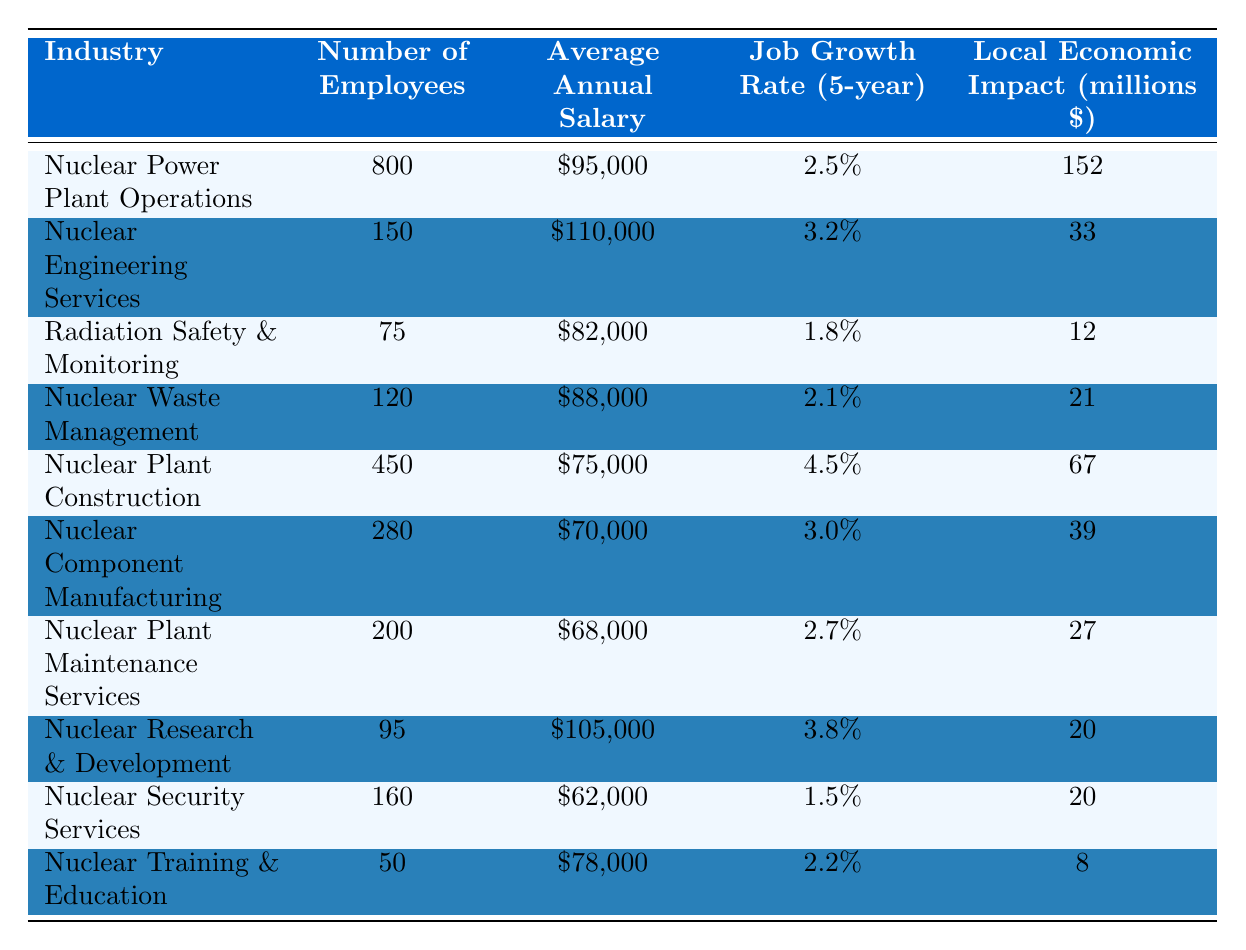What is the average annual salary of employees in Nuclear Power Plant Operations? The salary for Nuclear Power Plant Operations is listed as $95,000 in the table.
Answer: $95,000 Which industry has the highest job growth rate over the next five years? Nuclear Plant Construction has the highest job growth rate at 4.5% according to the table.
Answer: 4.5% What is the local economic impact of Nuclear Engineering Services? The table shows that the local economic impact of Nuclear Engineering Services is $33 million.
Answer: $33 million How many employees work in Nuclear Security Services? The table indicates that Nuclear Security Services employs 160 people.
Answer: 160 What is the total number of employees across all nuclear-related industries listed in the table? To find the total, sum the number of employees: 800 + 150 + 75 + 120 + 450 + 280 + 200 + 95 + 160 + 50 = 2080.
Answer: 2,080 Is the average annual salary for Nuclear Component Manufacturing greater than $75,000? The average annual salary for Nuclear Component Manufacturing is $70,000, which is less than $75,000.
Answer: No Which industry contributes the least to the local economy? Nuclear Training & Education contributes the least at $8 million, based on the local economic impact values in the table.
Answer: $8 million What is the difference in average annual salary between Nuclear Engineering Services and Nuclear Security Services? The average annual salary for Nuclear Engineering Services is $110,000 and for Nuclear Security Services is $62,000. The difference is $110,000 - $62,000 = $48,000.
Answer: $48,000 Are there more employees in Nuclear Plant Maintenance Services than in Nuclear Waste Management? Nuclear Plant Maintenance Services has 200 employees while Nuclear Waste Management has 120 employees. Therefore, there are more employees in Maintenance Services.
Answer: Yes What percentage of employees work in Nuclear Research & Development relative to the total number of employees? The total number of employees is 2,080, and those in Nuclear Research & Development are 95. The percentage is (95 / 2080) * 100 ≈ 4.57%.
Answer: 4.57% 